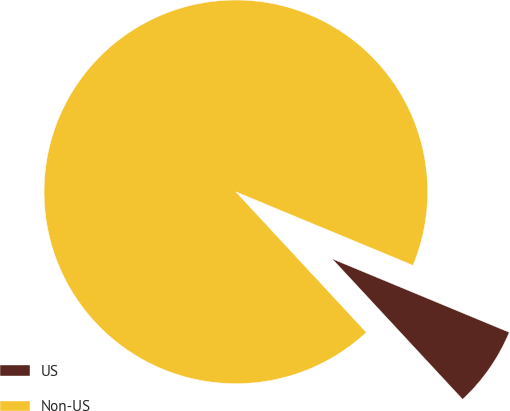Convert chart to OTSL. <chart><loc_0><loc_0><loc_500><loc_500><pie_chart><fcel>US<fcel>Non-US<nl><fcel>6.83%<fcel>93.17%<nl></chart> 